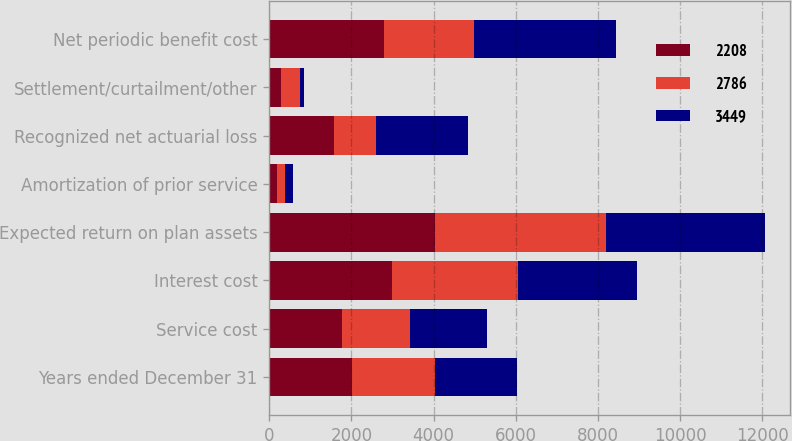Convert chart. <chart><loc_0><loc_0><loc_500><loc_500><stacked_bar_chart><ecel><fcel>Years ended December 31<fcel>Service cost<fcel>Interest cost<fcel>Expected return on plan assets<fcel>Amortization of prior service<fcel>Recognized net actuarial loss<fcel>Settlement/curtailment/other<fcel>Net periodic benefit cost<nl><fcel>2208<fcel>2015<fcel>1764<fcel>2990<fcel>4031<fcel>196<fcel>1577<fcel>290<fcel>2786<nl><fcel>2786<fcel>2014<fcel>1661<fcel>3058<fcel>4169<fcel>177<fcel>1020<fcel>461<fcel>2208<nl><fcel>3449<fcel>2013<fcel>1886<fcel>2906<fcel>3874<fcel>196<fcel>2231<fcel>104<fcel>3449<nl></chart> 